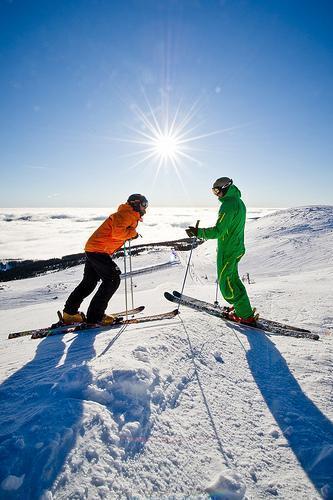How many people are in the picture?
Give a very brief answer. 2. 